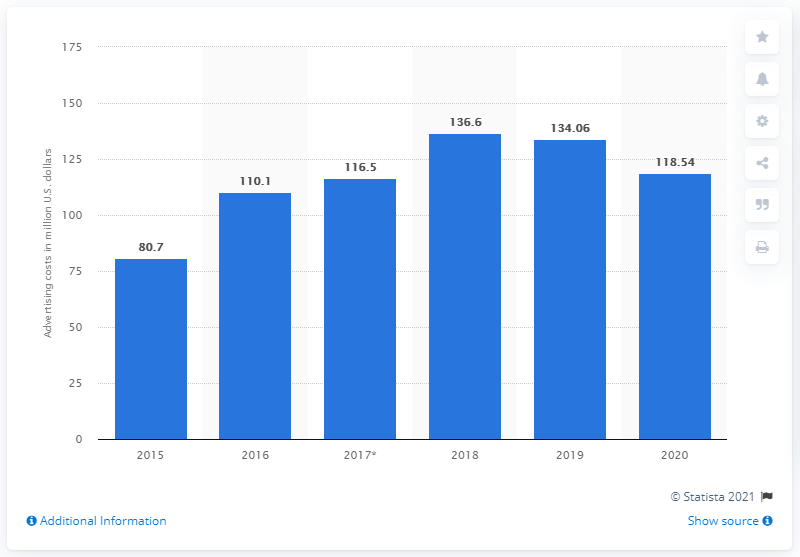Identify some key points in this picture. Abercrombie & Fitch spent 118.54 million dollars on advertising in 2020. 